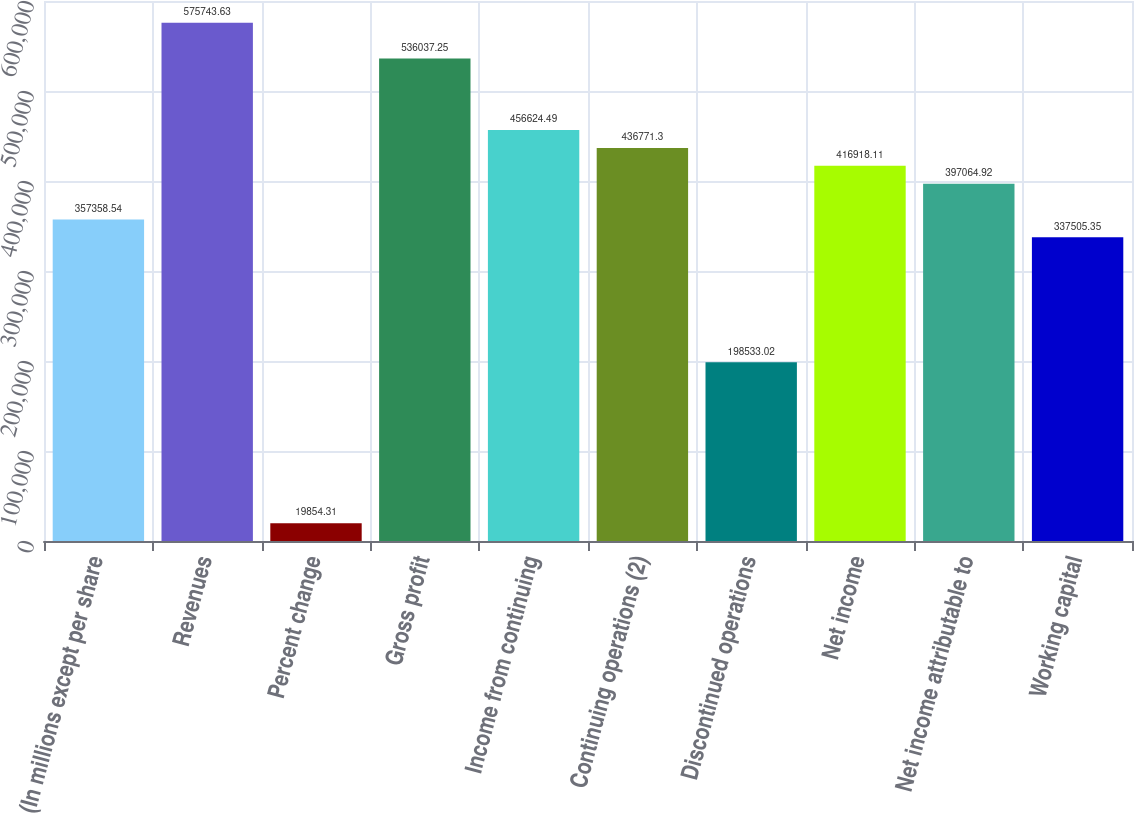<chart> <loc_0><loc_0><loc_500><loc_500><bar_chart><fcel>(In millions except per share<fcel>Revenues<fcel>Percent change<fcel>Gross profit<fcel>Income from continuing<fcel>Continuing operations (2)<fcel>Discontinued operations<fcel>Net income<fcel>Net income attributable to<fcel>Working capital<nl><fcel>357359<fcel>575744<fcel>19854.3<fcel>536037<fcel>456624<fcel>436771<fcel>198533<fcel>416918<fcel>397065<fcel>337505<nl></chart> 